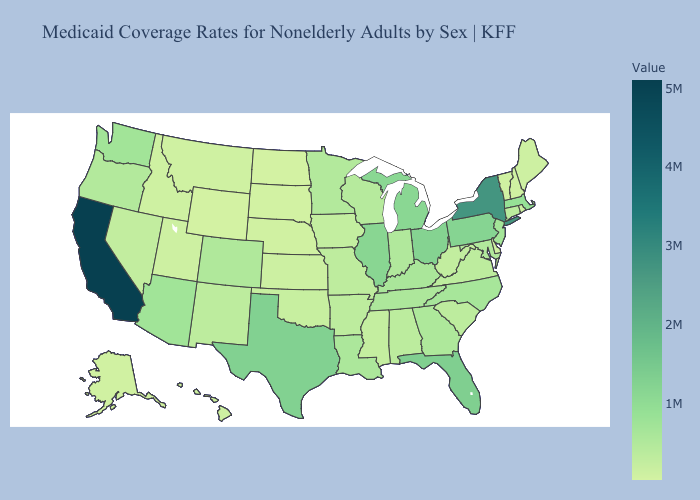Does Kansas have a higher value than North Carolina?
Quick response, please. No. Does Connecticut have the highest value in the USA?
Concise answer only. No. Is the legend a continuous bar?
Give a very brief answer. Yes. Does the map have missing data?
Be succinct. No. Is the legend a continuous bar?
Answer briefly. Yes. Does Wyoming have the lowest value in the USA?
Answer briefly. Yes. 